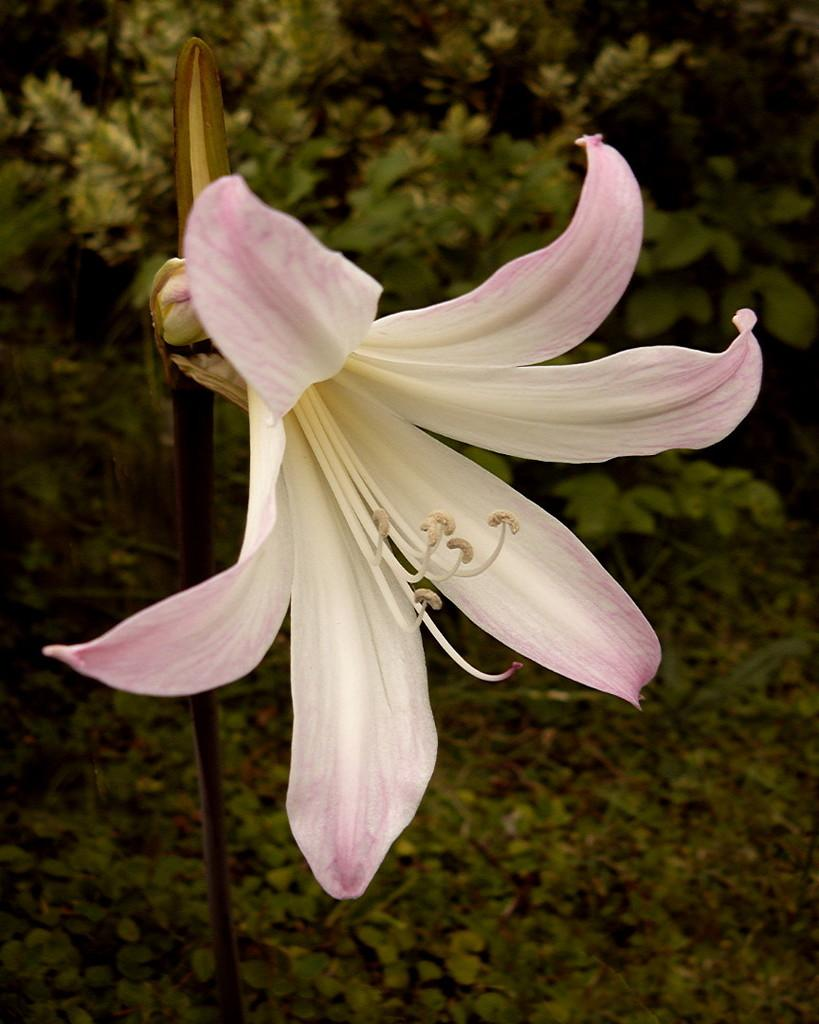What is the main subject of the image? There is a flower in the image. Can you describe the colors of the flower? The flower has pink and white colors. What can be seen in the background of the image? There are trees in the background of the image. How many degrees does the slave have in the image? There is no slave present in the image, and therefore no degrees can be attributed to them. 